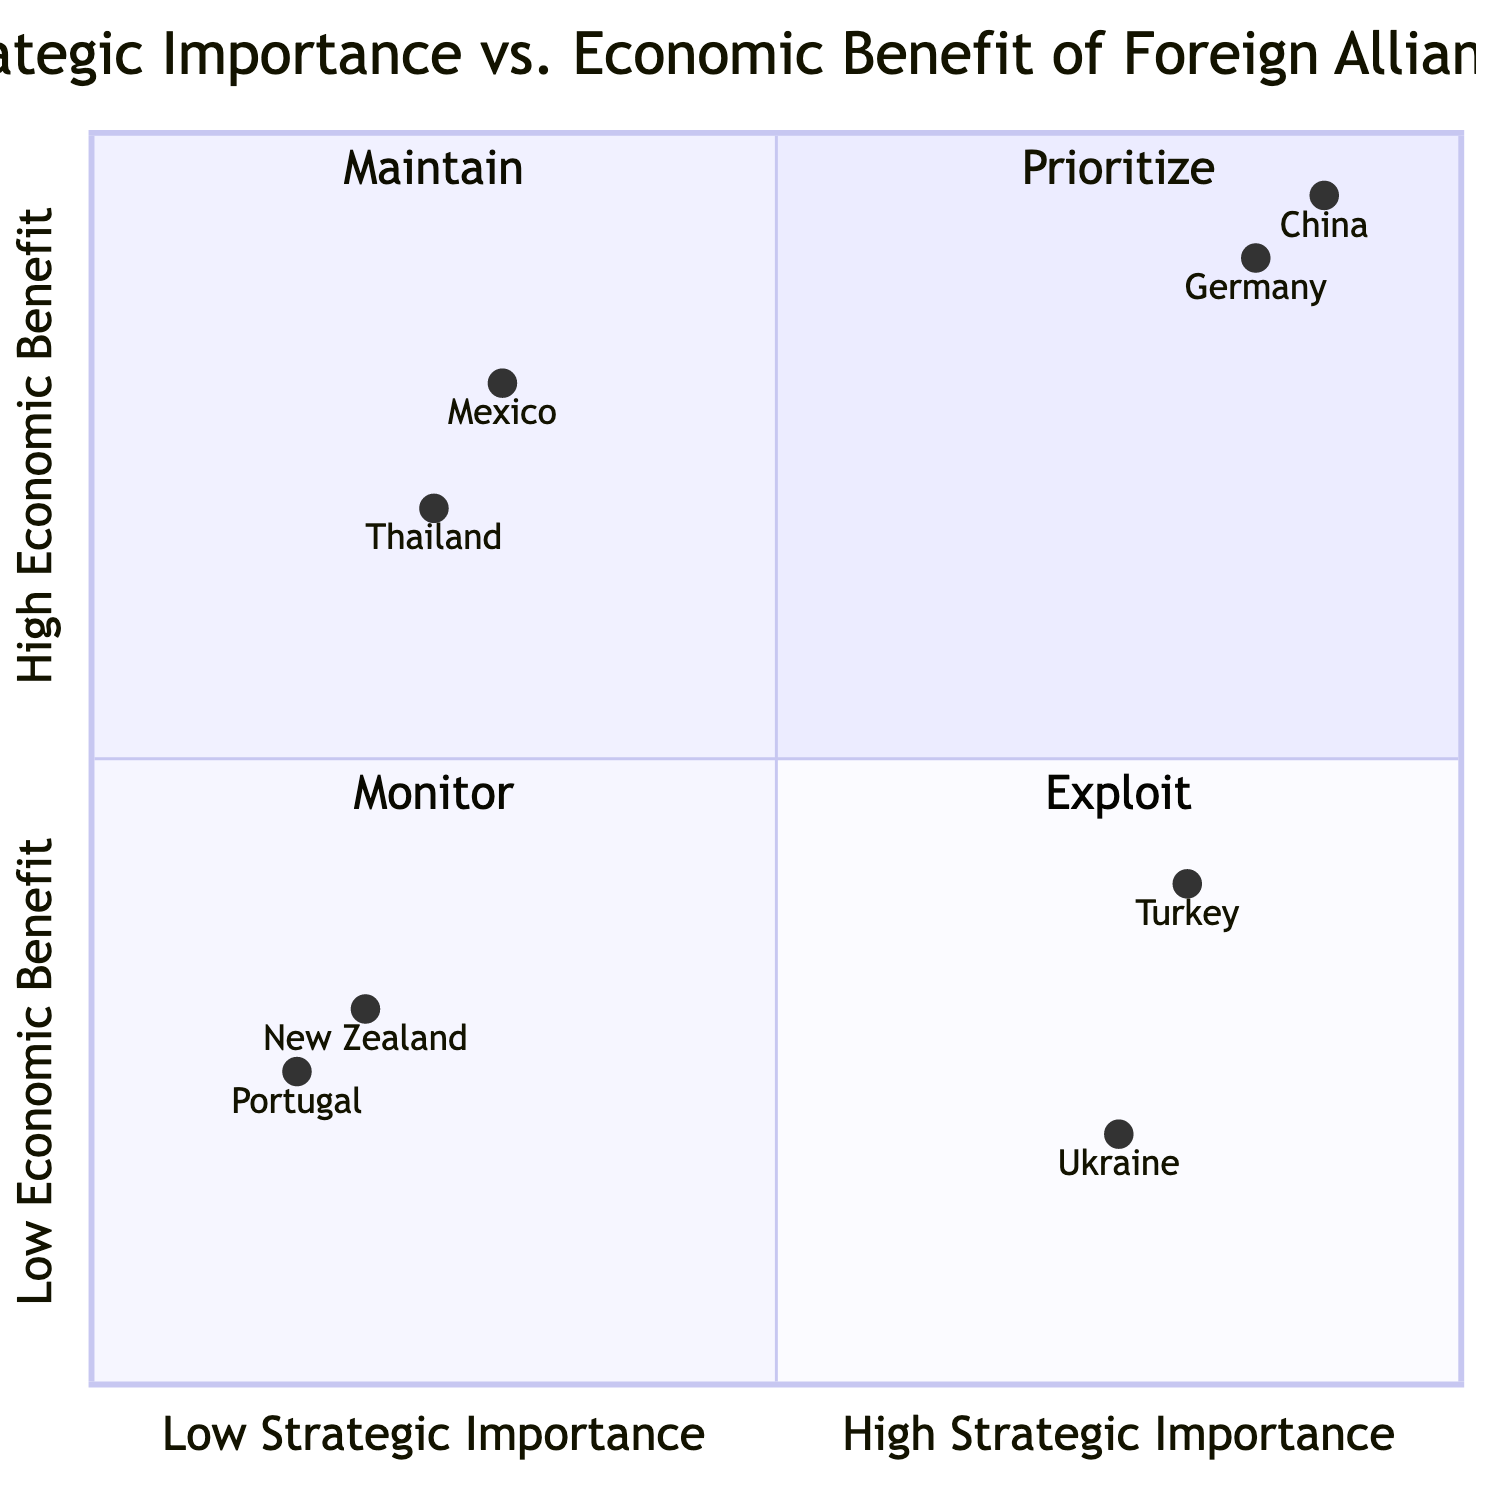What countries are in the "High Strategic Importance, High Economic Benefit" quadrant? The countries in this quadrant are China and Germany, as they both meet the criteria of having high strategic importance and high economic benefit.
Answer: China, Germany Which country has the highest strategic importance in the diagram? Among the countries represented, China has the highest strategic importance, as indicated by its position in the upper left quadrant where both strategic importance and economic benefit are high.
Answer: China How many countries have low economic benefit? There are four countries that fall into the low economic benefit category, as indicated by the quadrants that are on the lower half of the diagram.
Answer: Four Which quadrant contains Turkey? Turkey is located in the "High Strategic Importance, Low Economic Benefit" quadrant, as it demonstrates notable strategic significance but limited economic ties.
Answer: High Strategic Importance, Low Economic Benefit What is the economic benefit of Mexico? The economic benefit of Mexico is labeled as significant due to its status as a major trade partner through agreements such as NAFTA.
Answer: Significant trade partner Which country is in the "Low Strategic Importance, High Economic Benefit" quadrant? Mexico and Thailand are positioned in the "Low Strategic Importance, High Economic Benefit" quadrant, as they both provide substantial economic advantages despite lower strategic significance.
Answer: Mexico, Thailand What is the combined strategic importance level of New Zealand? New Zealand has a low strategic importance level, indicated by its position in the lower left quadrant, specifically marked as stable democracy, but with limited economic impact.
Answer: Low Which country features as a buffer against Russian influence? Ukraine is highlighted as a country serving as a buffer against Russian influence, though it has a lower economic benefit derived from this strategic position.
Answer: Ukraine What is the economic benefit associated with Germany? Germany’s economic benefit is noted as high technology exports, as per its classification in the high strategic and economic benefit quadrant.
Answer: High technology exports 